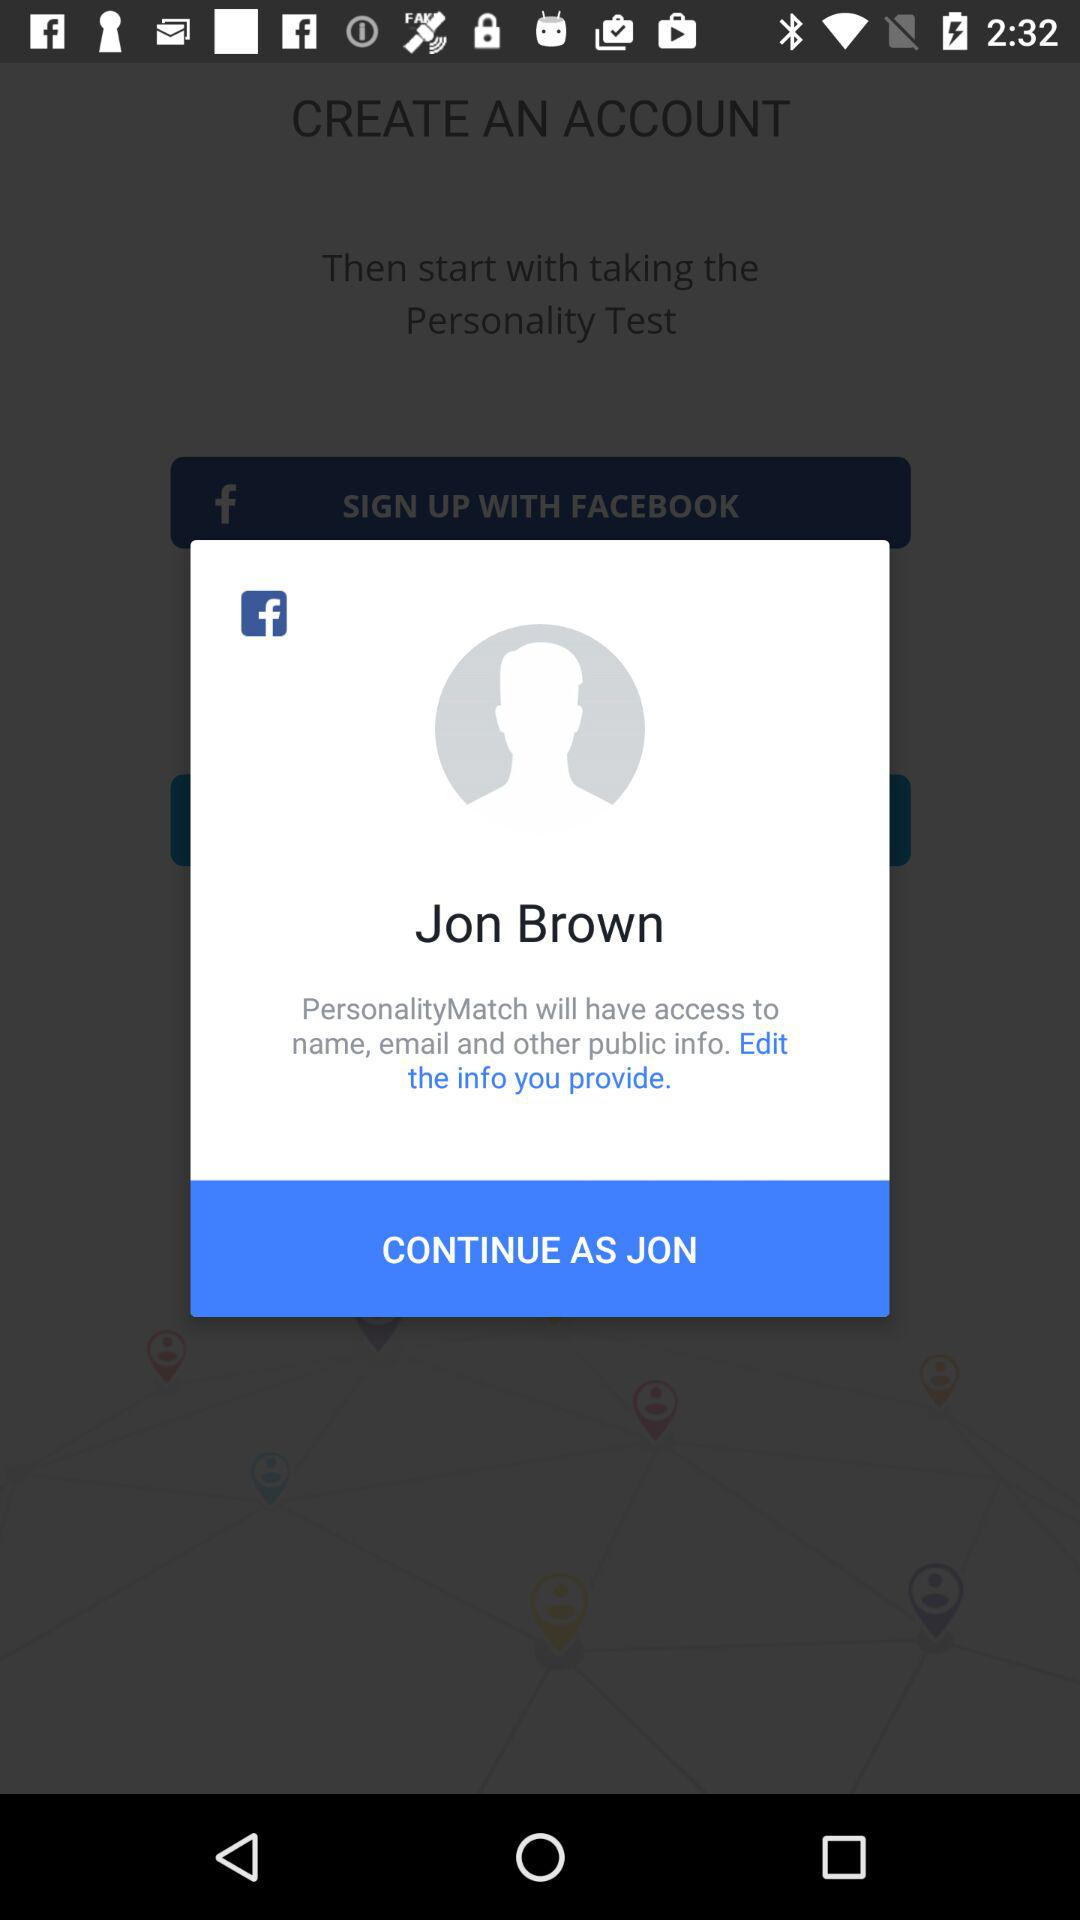What application is asking for permission? The application asking for permission is "PersonalityMatch". 